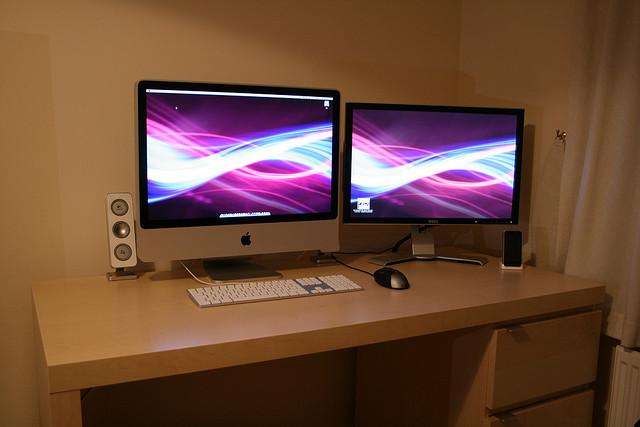Which monitor is larger?
Concise answer only. Left. How many screens are there?
Concise answer only. 2. Is there a phone on the desk?
Answer briefly. Yes. 